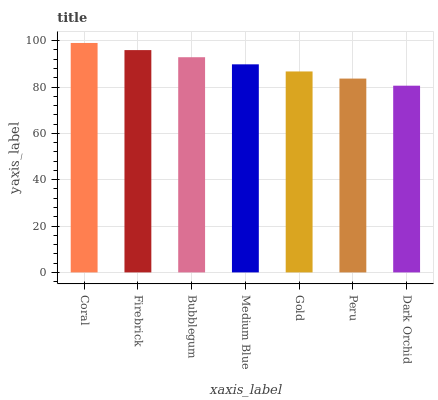Is Dark Orchid the minimum?
Answer yes or no. Yes. Is Coral the maximum?
Answer yes or no. Yes. Is Firebrick the minimum?
Answer yes or no. No. Is Firebrick the maximum?
Answer yes or no. No. Is Coral greater than Firebrick?
Answer yes or no. Yes. Is Firebrick less than Coral?
Answer yes or no. Yes. Is Firebrick greater than Coral?
Answer yes or no. No. Is Coral less than Firebrick?
Answer yes or no. No. Is Medium Blue the high median?
Answer yes or no. Yes. Is Medium Blue the low median?
Answer yes or no. Yes. Is Peru the high median?
Answer yes or no. No. Is Firebrick the low median?
Answer yes or no. No. 